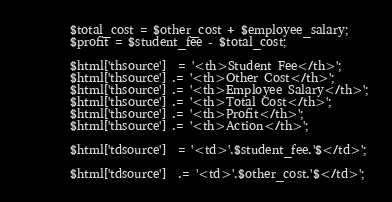Convert code to text. <code><loc_0><loc_0><loc_500><loc_500><_PHP_>
        $total_cost = $other_cost + $employee_salary;
        $profit = $student_fee - $total_cost;

        $html['thsource']  = '<th>Student Fee</th>';
        $html['thsource'] .= '<th>Other Cost</th>';
        $html['thsource'] .= '<th>Employee Salary</th>';
        $html['thsource'] .= '<th>Total Cost</th>';
        $html['thsource'] .= '<th>Profit</th>';
        $html['thsource'] .= '<th>Action</th>';

        $html['tdsource']  = '<td>'.$student_fee.'$</td>';

        $html['tdsource']  .= '<td>'.$other_cost.'$</td>';
</code> 